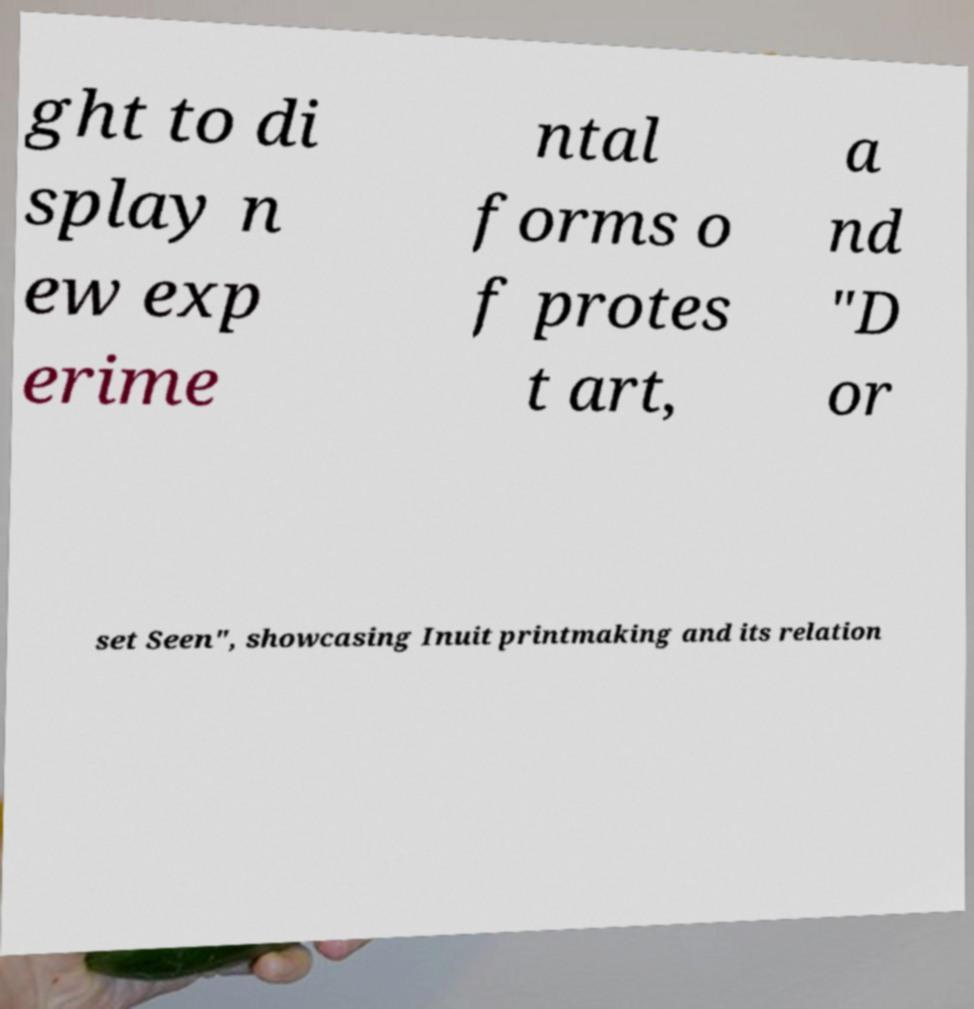Can you accurately transcribe the text from the provided image for me? ght to di splay n ew exp erime ntal forms o f protes t art, a nd "D or set Seen", showcasing Inuit printmaking and its relation 